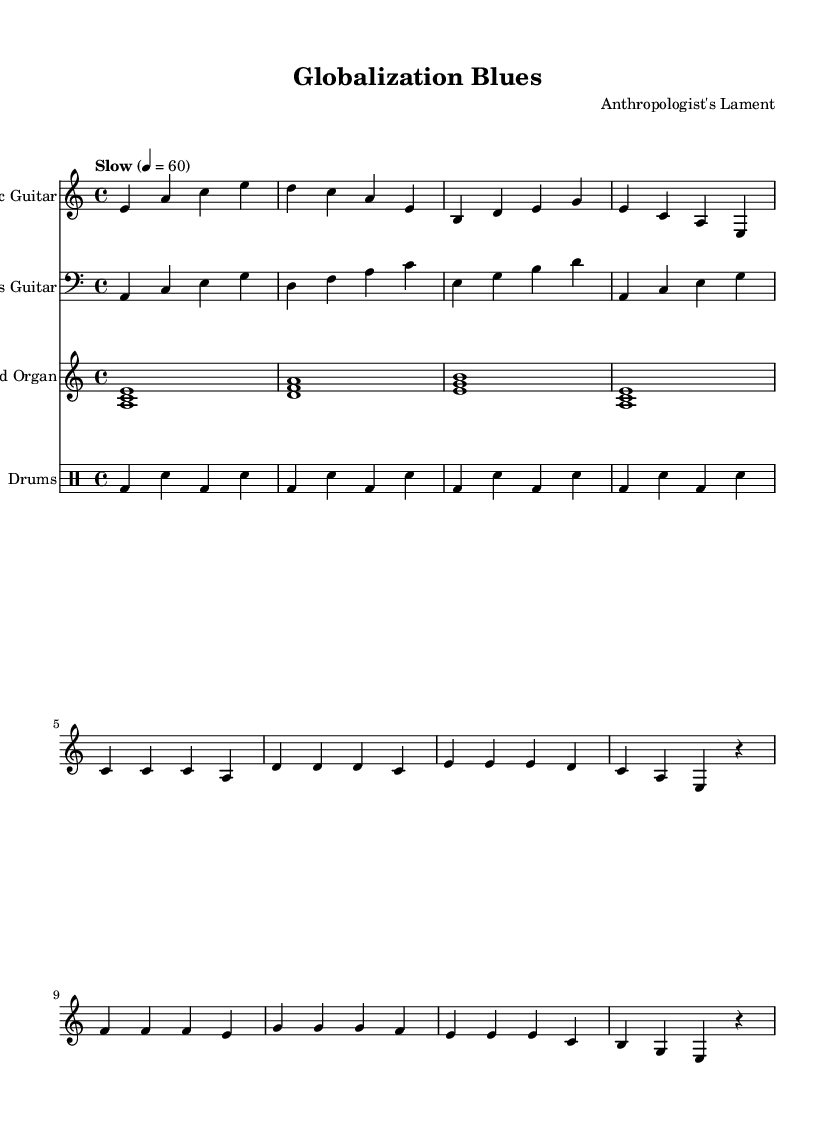What is the key signature of this music? The key signature is A minor, as indicated at the beginning of the score with one sharp. A minor shares the same key signature as C major, which has no sharps or flats, but here it is noted specifically for A minor context.
Answer: A minor What is the time signature of this music? The time signature specified in the score is 4/4, which indicates that there are four beats in each measure and a quarter note gets one beat. This can be seen as it is prominently displayed at the beginning of the piece.
Answer: 4/4 What is the tempo marking for this piece? The tempo marking is indicated as "Slow" with a metronome setting of 60 beats per minute. This directs the performers to play at a relaxed pace, which is common in contemplative blues music.
Answer: Slow How many measures are in the verse section? The verse section contains four measures, which can be determined by counting the groups of bars within the verse itself. Each grouping of notes clusters together in a total of four distinct measures.
Answer: Four In what way is the bass guitar part characterized? The bass guitar part is characterized by a walking bass line, often found in blues music, providing a rhythmic foundation. This can be identified by the pattern of notes that create a flowing movement through the chord changes.
Answer: Walking bass line What instruments are included in this score? The score includes Electric Guitar, Bass Guitar, Hammond Organ, and Drums, which are typical for Electric Blues compositions. Each instrument is assigned to its own staff, making them easy to identify and differentiate.
Answer: Electric Guitar, Bass Guitar, Hammond Organ, Drums What does the use of silence (rests) indicate in this piece? The use of silence, represented as rests, indicates moments where the instrument does not play, creating space for emphasis or allowing tension to build. In this piece, it serves to accentuate the phrasing of the melody and creates a more contemplative mood.
Answer: Silence (rests) 